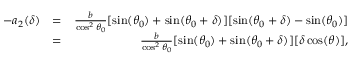Convert formula to latex. <formula><loc_0><loc_0><loc_500><loc_500>\begin{array} { r l r } { - a _ { 2 } ( \delta ) } & { = } & { \frac { b } { \cos ^ { 2 } \theta _ { 0 } } [ \sin ( \theta _ { 0 } ) + \sin ( \theta _ { 0 } + \delta ) ] [ \sin ( \theta _ { 0 } + \delta ) - \sin ( \theta _ { 0 } ) ] } \\ & { = } & { \frac { b } { \cos ^ { 2 } \theta _ { 0 } } [ \sin ( \theta _ { 0 } ) + \sin ( \theta _ { 0 } + \delta ) ] [ \delta \cos ( \theta ) ] , } \end{array}</formula> 